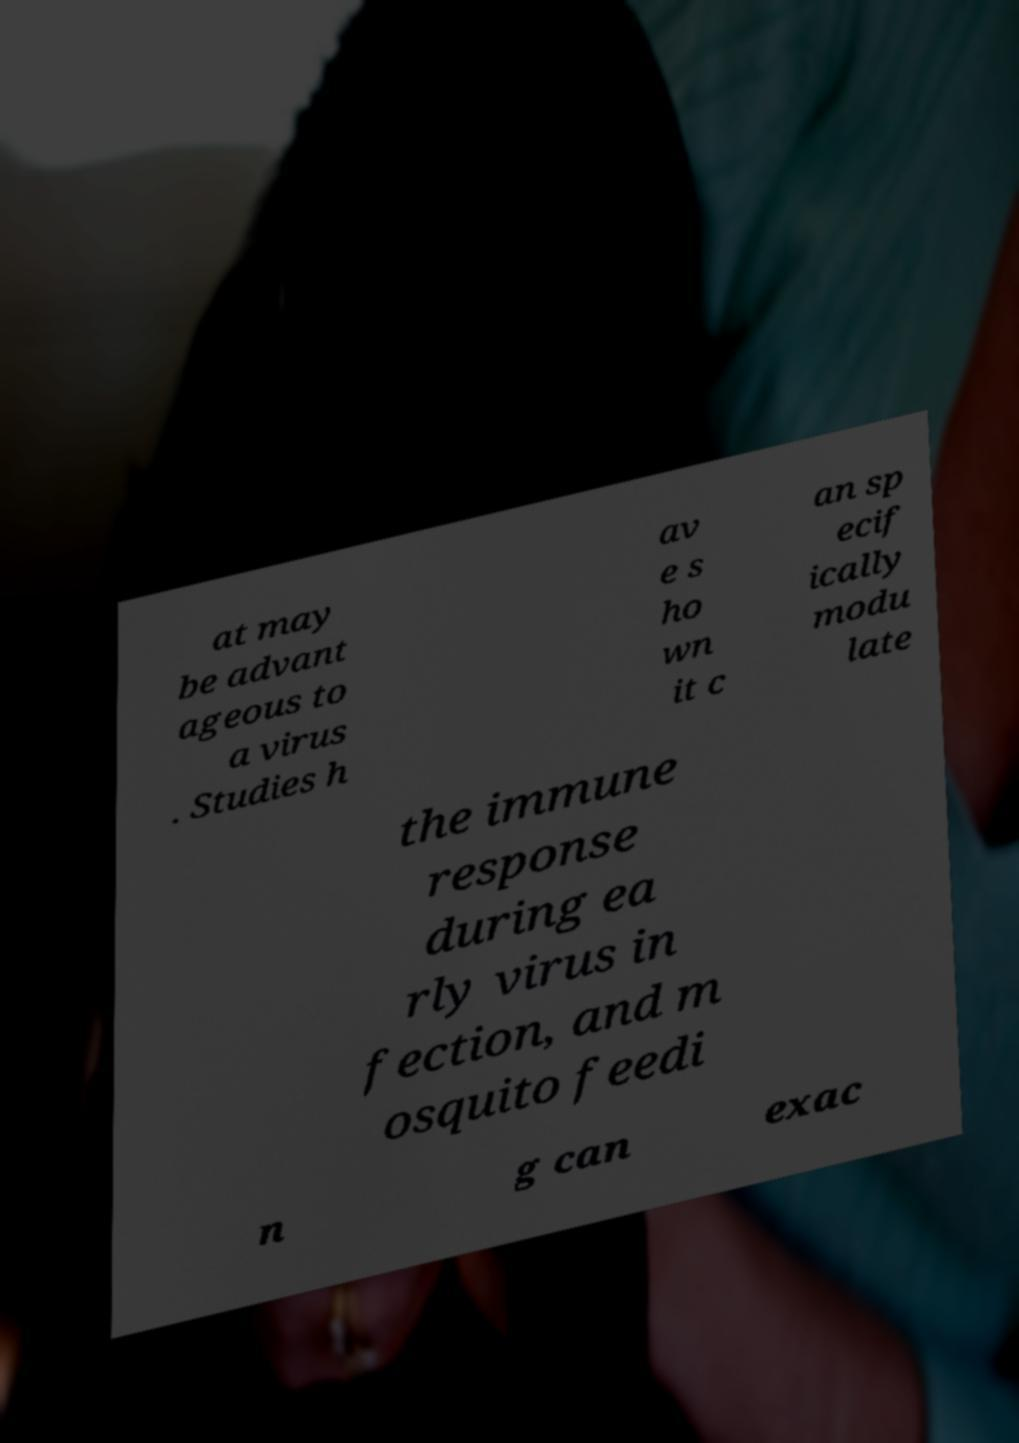What messages or text are displayed in this image? I need them in a readable, typed format. at may be advant ageous to a virus . Studies h av e s ho wn it c an sp ecif ically modu late the immune response during ea rly virus in fection, and m osquito feedi n g can exac 